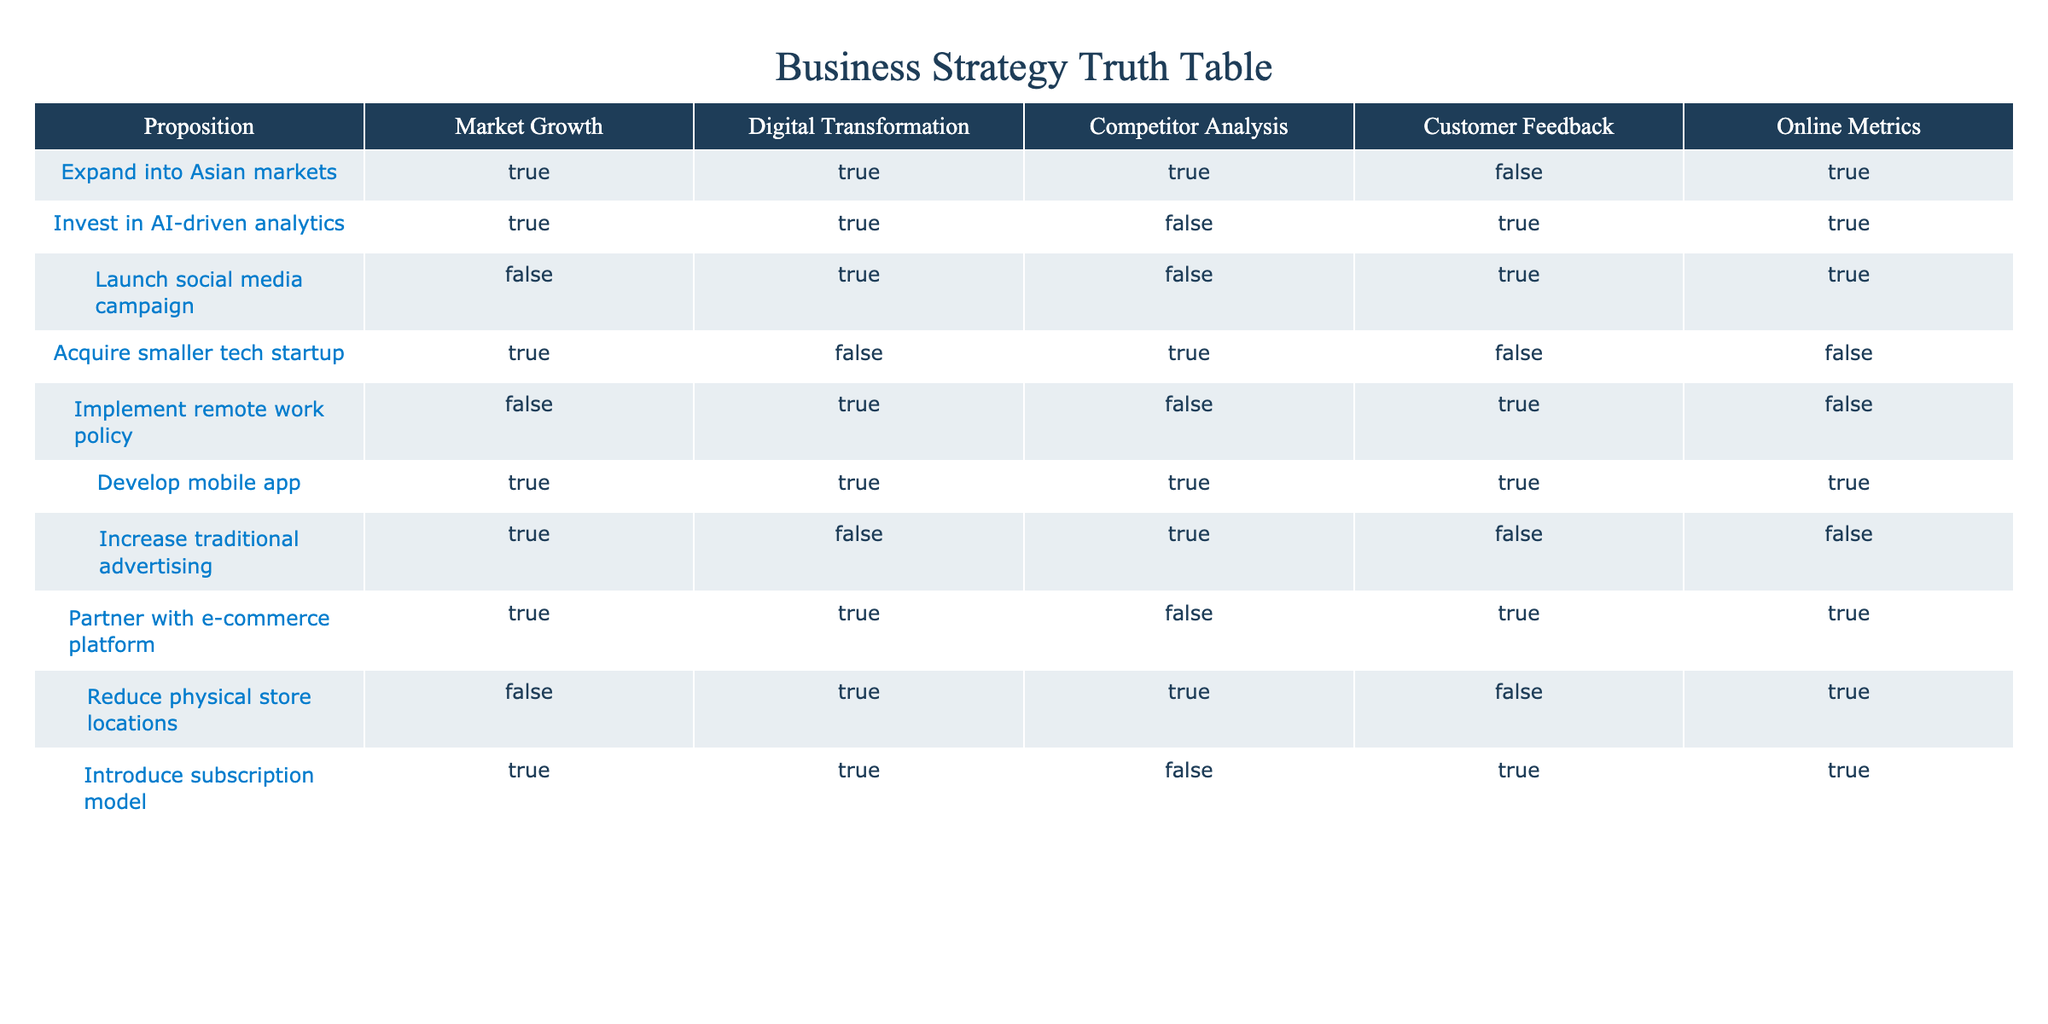What propositions involve digital transformation? To find the propositions involving digital transformation, I look through the "Digital Transformation" column for entries marked as TRUE. The propositions "Expand into Asian markets," "Invest in AI-driven analytics," "Launch social media campaign," "Develop mobile app," "Partner with e-commerce platform," and "Introduce subscription model" all have TRUE in this column.
Answer: Expand into Asian markets, Invest in AI-driven analytics, Launch social media campaign, Develop mobile app, Partner with e-commerce platform, Introduce subscription model Which proposition has the highest number of TRUE values across other columns? To determine the proposition with the highest number of TRUE values, I will count the TRUE values in each row for the columns "Market Growth," "Digital Transformation," "Competitor Analysis," "Customer Feedback," and "Online Metrics." The row for "Develop mobile app" has TRUE in all columns, totaling 5 TRUE values, which is the most among all propositions.
Answer: Develop mobile app Is there any proposition that combines digital transformation and customer feedback? I need to check the "Digital Transformation" and "Customer Feedback" columns for propositions that have a TRUE value in both. The propositions "Invest in AI-driven analytics," "Launch social media campaign," "Develop mobile app," "Partner with e-commerce platform," and "Introduce subscription model" satisfy this condition as they have TRUE in both columns.
Answer: Invest in AI-driven analytics, Launch social media campaign, Develop mobile app, Partner with e-commerce platform, Introduce subscription model Which propositions are TRUE for both expanding into Asian markets and acquiring a smaller tech startup? I look at the rows where "Expand into Asian markets" and "Acquire smaller tech startup" are both TRUE. However, both cannot be TRUE simultaneously since they cannot share the same row in the table. Therefore, there are no propositions that meet this condition.
Answer: None What percentage of propositions involve customer feedback? There are 10 propositions listed, and I need to count how many of them have TRUE under "Customer Feedback." The TRUE values appear in the propositions "Invest in AI-driven analytics," "Launch social media campaign," "Develop mobile app," "Partner with e-commerce platform," and "Introduce subscription model," which totals 5. Therefore, the percentage is (5/10) * 100 = 50%.
Answer: 50% Which propositions exclude both digital transformation and customer feedback? To find propositions that exclude both digital transformation and customer feedback, I will look for rows where both "Digital Transformation" and "Customer Feedback" are FALSE. The propositions "Acquire smaller tech startup" and "Increase traditional advertising" meet this criterion.
Answer: Acquire smaller tech startup, Increase traditional advertising Are there any propositions that relate to reducing physical store locations? I need to check the "Proposition" column for any mention of reducing physical store locations. The row "Reduce physical store locations" shows it as a proposition and has FALSE for customer feedback and TRUE for other metrics. Hence, this is the only entry related to the query.
Answer: Reduce physical store locations How many propositions have TRUE for online metrics? I look for the entries in the "Online Metrics" column that indicate TRUE. The propositions "Expand into Asian markets," "Invest in AI-driven analytics," "Launch social media campaign," "Develop mobile app," "Partner with e-commerce platform," and "Introduce subscription model" show TRUE, resulting in a total of 6.
Answer: 6 Which proposition relates to digital transformation but not to market growth? I need to identify entries that are TRUE under "Digital Transformation" but FALSE under "Market Growth." The proposition "Acquire smaller tech startup" meets this condition as it has TRUE for digital transformation and FALSE for market growth.
Answer: Acquire smaller tech startup 